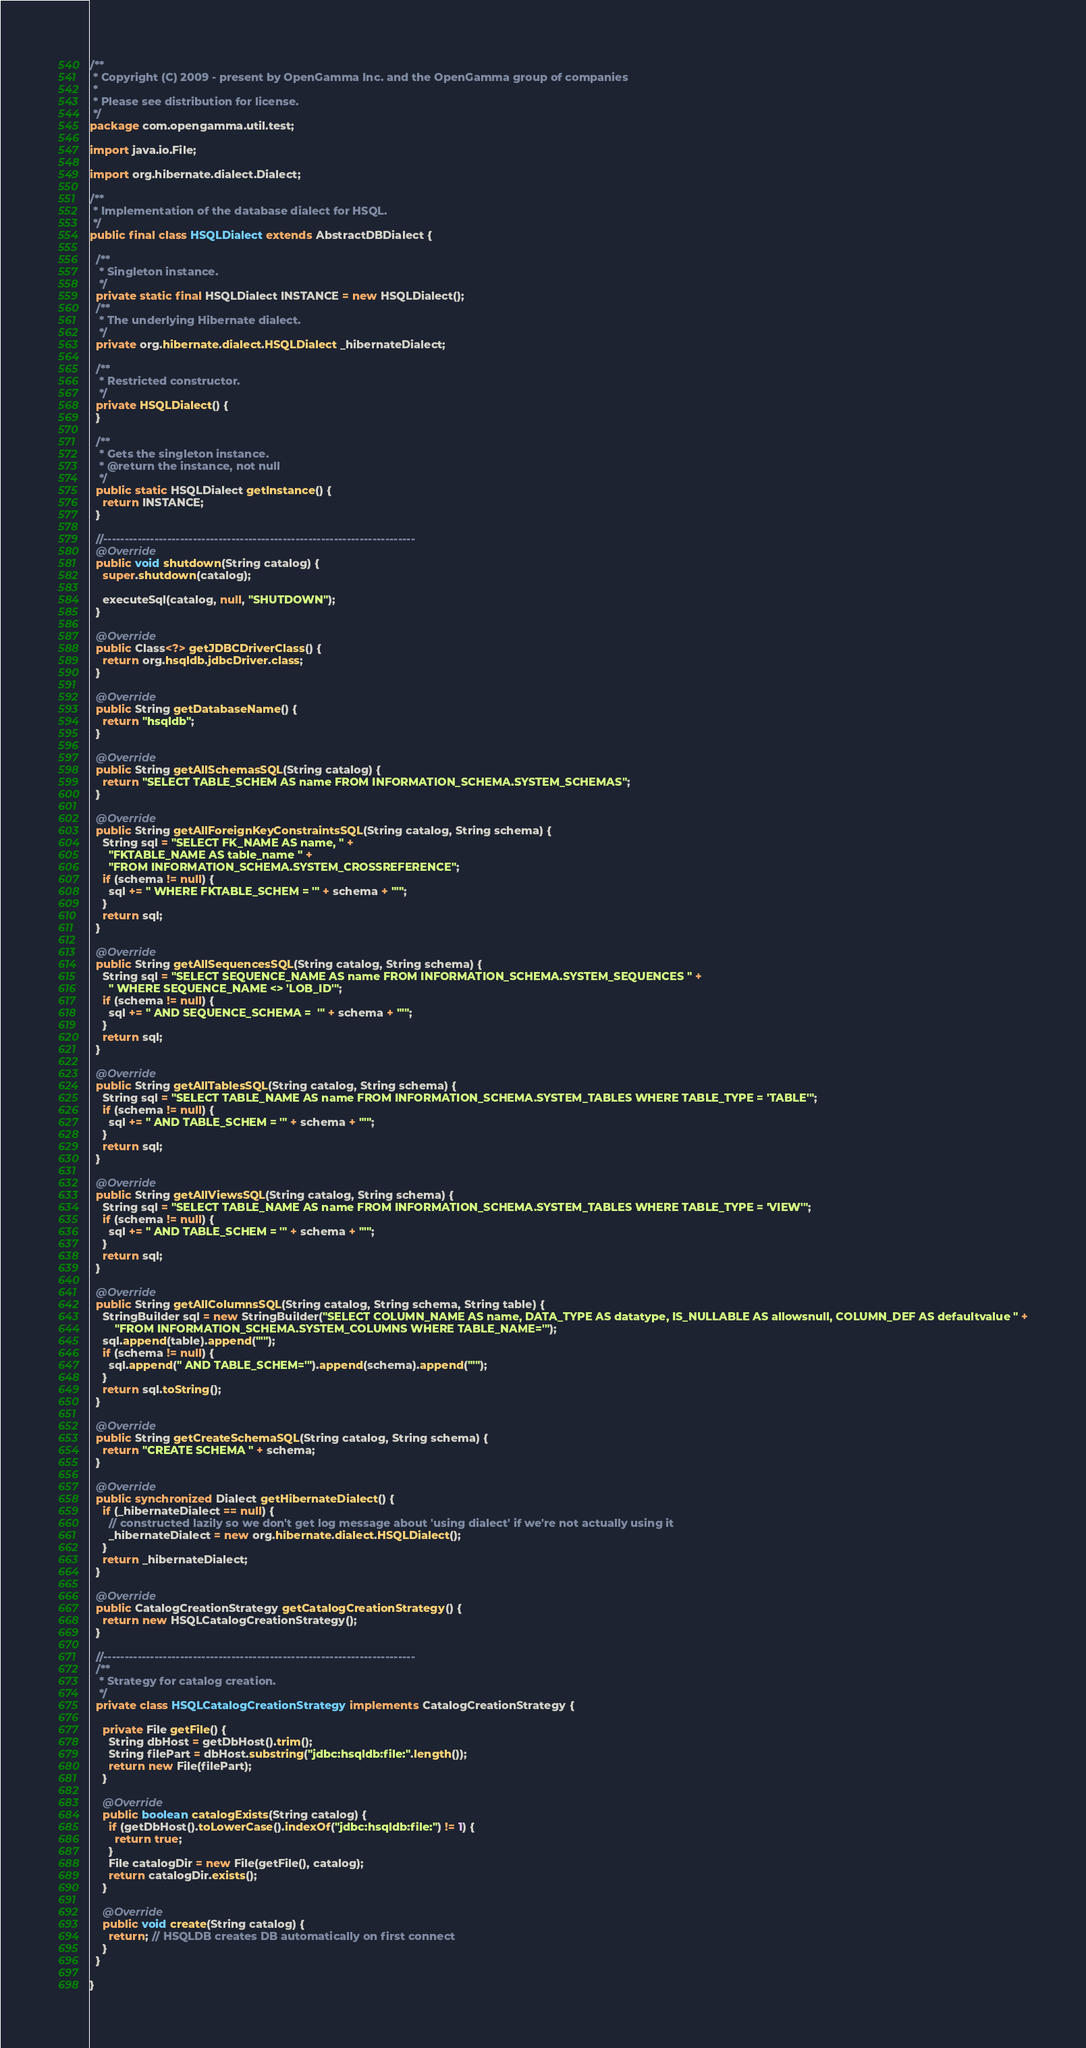<code> <loc_0><loc_0><loc_500><loc_500><_Java_>/**
 * Copyright (C) 2009 - present by OpenGamma Inc. and the OpenGamma group of companies
 *
 * Please see distribution for license.
 */
package com.opengamma.util.test;

import java.io.File;

import org.hibernate.dialect.Dialect;

/**
 * Implementation of the database dialect for HSQL.
 */
public final class HSQLDialect extends AbstractDBDialect {
  
  /**
   * Singleton instance.
   */
  private static final HSQLDialect INSTANCE = new HSQLDialect(); 
  /**
   * The underlying Hibernate dialect.
   */
  private org.hibernate.dialect.HSQLDialect _hibernateDialect;

  /**
   * Restricted constructor.
   */
  private HSQLDialect() {
  }

  /**
   * Gets the singleton instance.
   * @return the instance, not null
   */
  public static HSQLDialect getInstance() {
    return INSTANCE;
  }

  //-------------------------------------------------------------------------
  @Override
  public void shutdown(String catalog) {
    super.shutdown(catalog);
    
    executeSql(catalog, null, "SHUTDOWN");
  }

  @Override
  public Class<?> getJDBCDriverClass() {
    return org.hsqldb.jdbcDriver.class;
  }

  @Override
  public String getDatabaseName() {
    return "hsqldb";
  }

  @Override
  public String getAllSchemasSQL(String catalog) {
    return "SELECT TABLE_SCHEM AS name FROM INFORMATION_SCHEMA.SYSTEM_SCHEMAS";
  }

  @Override
  public String getAllForeignKeyConstraintsSQL(String catalog, String schema) {
    String sql = "SELECT FK_NAME AS name, " +
      "FKTABLE_NAME AS table_name " +
      "FROM INFORMATION_SCHEMA.SYSTEM_CROSSREFERENCE";
    if (schema != null) {
      sql += " WHERE FKTABLE_SCHEM = '" + schema + "'";
    }
    return sql;
  }

  @Override
  public String getAllSequencesSQL(String catalog, String schema) {
    String sql = "SELECT SEQUENCE_NAME AS name FROM INFORMATION_SCHEMA.SYSTEM_SEQUENCES " +
      " WHERE SEQUENCE_NAME <> 'LOB_ID'";
    if (schema != null) {
      sql += " AND SEQUENCE_SCHEMA =  '" + schema + "'";
    }
    return sql;
  }

  @Override
  public String getAllTablesSQL(String catalog, String schema) {
    String sql = "SELECT TABLE_NAME AS name FROM INFORMATION_SCHEMA.SYSTEM_TABLES WHERE TABLE_TYPE = 'TABLE'";
    if (schema != null) {
      sql += " AND TABLE_SCHEM = '" + schema + "'";
    }
    return sql;
  }
  
  @Override
  public String getAllViewsSQL(String catalog, String schema) {
    String sql = "SELECT TABLE_NAME AS name FROM INFORMATION_SCHEMA.SYSTEM_TABLES WHERE TABLE_TYPE = 'VIEW'";
    if (schema != null) {
      sql += " AND TABLE_SCHEM = '" + schema + "'";
    }
    return sql;
  }

  @Override
  public String getAllColumnsSQL(String catalog, String schema, String table) {
    StringBuilder sql = new StringBuilder("SELECT COLUMN_NAME AS name, DATA_TYPE AS datatype, IS_NULLABLE AS allowsnull, COLUMN_DEF AS defaultvalue " +
        "FROM INFORMATION_SCHEMA.SYSTEM_COLUMNS WHERE TABLE_NAME='");
    sql.append(table).append("'");
    if (schema != null) {
      sql.append(" AND TABLE_SCHEM='").append(schema).append("'");
    }
    return sql.toString();
  }

  @Override
  public String getCreateSchemaSQL(String catalog, String schema) {
    return "CREATE SCHEMA " + schema;
  }

  @Override
  public synchronized Dialect getHibernateDialect() {
    if (_hibernateDialect == null) {
      // constructed lazily so we don't get log message about 'using dialect' if we're not actually using it
      _hibernateDialect = new org.hibernate.dialect.HSQLDialect();
    }
    return _hibernateDialect;
  }

  @Override
  public CatalogCreationStrategy getCatalogCreationStrategy() {
    return new HSQLCatalogCreationStrategy();
  }

  //-------------------------------------------------------------------------
  /**
   * Strategy for catalog creation.
   */
  private class HSQLCatalogCreationStrategy implements CatalogCreationStrategy {

    private File getFile() {
      String dbHost = getDbHost().trim();
      String filePart = dbHost.substring("jdbc:hsqldb:file:".length());
      return new File(filePart);
    }

    @Override
    public boolean catalogExists(String catalog) {
      if (getDbHost().toLowerCase().indexOf("jdbc:hsqldb:file:") != 1) {
        return true;
      }
      File catalogDir = new File(getFile(), catalog);
      return catalogDir.exists();
    }

    @Override
    public void create(String catalog) {
      return; // HSQLDB creates DB automatically on first connect
    }
  }

}
</code> 